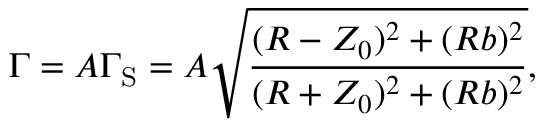<formula> <loc_0><loc_0><loc_500><loc_500>\Gamma = A \Gamma _ { S } = A \sqrt { \frac { ( R - Z _ { 0 } ) ^ { 2 } + ( R b ) ^ { 2 } } { ( R + Z _ { 0 } ) ^ { 2 } + ( R b ) ^ { 2 } } } ,</formula> 